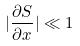Convert formula to latex. <formula><loc_0><loc_0><loc_500><loc_500>| \frac { \partial S } { \partial x } | \ll 1</formula> 